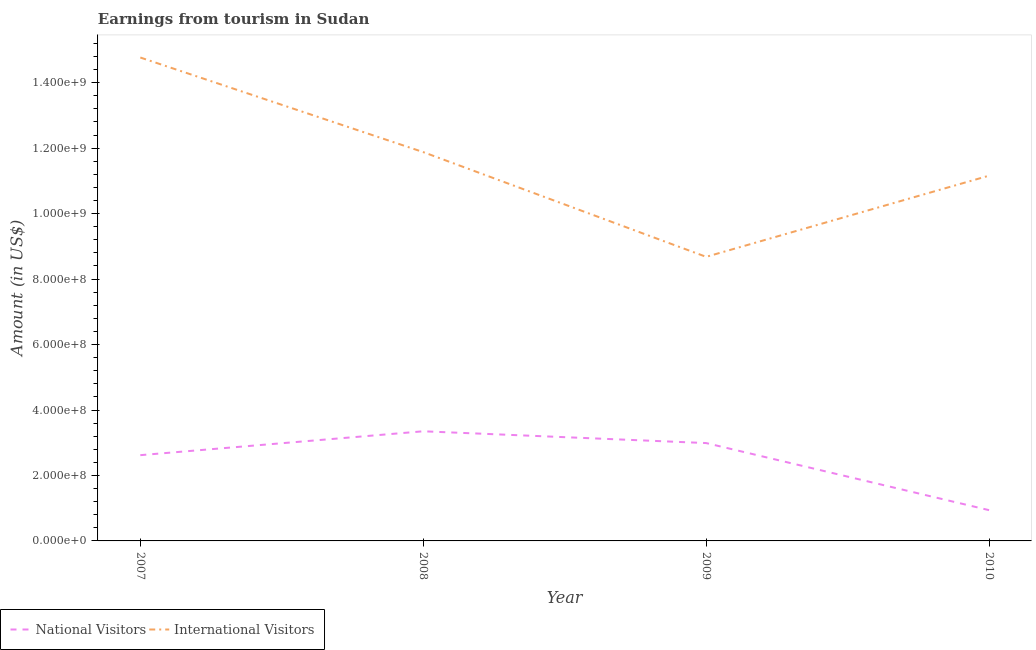How many different coloured lines are there?
Your response must be concise. 2. Does the line corresponding to amount earned from international visitors intersect with the line corresponding to amount earned from national visitors?
Provide a succinct answer. No. What is the amount earned from international visitors in 2009?
Your answer should be compact. 8.68e+08. Across all years, what is the maximum amount earned from national visitors?
Provide a short and direct response. 3.35e+08. Across all years, what is the minimum amount earned from international visitors?
Offer a terse response. 8.68e+08. What is the total amount earned from national visitors in the graph?
Offer a very short reply. 9.90e+08. What is the difference between the amount earned from international visitors in 2008 and that in 2010?
Make the answer very short. 7.20e+07. What is the difference between the amount earned from national visitors in 2008 and the amount earned from international visitors in 2009?
Make the answer very short. -5.33e+08. What is the average amount earned from international visitors per year?
Ensure brevity in your answer.  1.16e+09. In the year 2008, what is the difference between the amount earned from international visitors and amount earned from national visitors?
Provide a succinct answer. 8.53e+08. What is the ratio of the amount earned from national visitors in 2007 to that in 2008?
Keep it short and to the point. 0.78. Is the amount earned from international visitors in 2008 less than that in 2009?
Offer a terse response. No. Is the difference between the amount earned from national visitors in 2008 and 2010 greater than the difference between the amount earned from international visitors in 2008 and 2010?
Make the answer very short. Yes. What is the difference between the highest and the second highest amount earned from national visitors?
Provide a short and direct response. 3.60e+07. What is the difference between the highest and the lowest amount earned from international visitors?
Ensure brevity in your answer.  6.09e+08. Is the amount earned from international visitors strictly greater than the amount earned from national visitors over the years?
Your answer should be compact. Yes. How many years are there in the graph?
Ensure brevity in your answer.  4. What is the title of the graph?
Make the answer very short. Earnings from tourism in Sudan. What is the label or title of the X-axis?
Your answer should be compact. Year. What is the label or title of the Y-axis?
Make the answer very short. Amount (in US$). What is the Amount (in US$) in National Visitors in 2007?
Provide a short and direct response. 2.62e+08. What is the Amount (in US$) of International Visitors in 2007?
Give a very brief answer. 1.48e+09. What is the Amount (in US$) of National Visitors in 2008?
Make the answer very short. 3.35e+08. What is the Amount (in US$) of International Visitors in 2008?
Ensure brevity in your answer.  1.19e+09. What is the Amount (in US$) of National Visitors in 2009?
Your answer should be compact. 2.99e+08. What is the Amount (in US$) of International Visitors in 2009?
Keep it short and to the point. 8.68e+08. What is the Amount (in US$) in National Visitors in 2010?
Provide a short and direct response. 9.40e+07. What is the Amount (in US$) in International Visitors in 2010?
Your response must be concise. 1.12e+09. Across all years, what is the maximum Amount (in US$) in National Visitors?
Provide a short and direct response. 3.35e+08. Across all years, what is the maximum Amount (in US$) in International Visitors?
Offer a terse response. 1.48e+09. Across all years, what is the minimum Amount (in US$) of National Visitors?
Offer a terse response. 9.40e+07. Across all years, what is the minimum Amount (in US$) of International Visitors?
Offer a very short reply. 8.68e+08. What is the total Amount (in US$) in National Visitors in the graph?
Ensure brevity in your answer.  9.90e+08. What is the total Amount (in US$) in International Visitors in the graph?
Offer a very short reply. 4.65e+09. What is the difference between the Amount (in US$) of National Visitors in 2007 and that in 2008?
Ensure brevity in your answer.  -7.30e+07. What is the difference between the Amount (in US$) of International Visitors in 2007 and that in 2008?
Keep it short and to the point. 2.89e+08. What is the difference between the Amount (in US$) of National Visitors in 2007 and that in 2009?
Ensure brevity in your answer.  -3.70e+07. What is the difference between the Amount (in US$) in International Visitors in 2007 and that in 2009?
Your answer should be compact. 6.09e+08. What is the difference between the Amount (in US$) in National Visitors in 2007 and that in 2010?
Make the answer very short. 1.68e+08. What is the difference between the Amount (in US$) of International Visitors in 2007 and that in 2010?
Your answer should be very brief. 3.61e+08. What is the difference between the Amount (in US$) of National Visitors in 2008 and that in 2009?
Offer a very short reply. 3.60e+07. What is the difference between the Amount (in US$) in International Visitors in 2008 and that in 2009?
Your answer should be compact. 3.20e+08. What is the difference between the Amount (in US$) in National Visitors in 2008 and that in 2010?
Keep it short and to the point. 2.41e+08. What is the difference between the Amount (in US$) in International Visitors in 2008 and that in 2010?
Offer a terse response. 7.20e+07. What is the difference between the Amount (in US$) of National Visitors in 2009 and that in 2010?
Your answer should be compact. 2.05e+08. What is the difference between the Amount (in US$) of International Visitors in 2009 and that in 2010?
Offer a terse response. -2.48e+08. What is the difference between the Amount (in US$) in National Visitors in 2007 and the Amount (in US$) in International Visitors in 2008?
Provide a short and direct response. -9.26e+08. What is the difference between the Amount (in US$) in National Visitors in 2007 and the Amount (in US$) in International Visitors in 2009?
Ensure brevity in your answer.  -6.06e+08. What is the difference between the Amount (in US$) of National Visitors in 2007 and the Amount (in US$) of International Visitors in 2010?
Provide a short and direct response. -8.54e+08. What is the difference between the Amount (in US$) in National Visitors in 2008 and the Amount (in US$) in International Visitors in 2009?
Offer a terse response. -5.33e+08. What is the difference between the Amount (in US$) in National Visitors in 2008 and the Amount (in US$) in International Visitors in 2010?
Ensure brevity in your answer.  -7.81e+08. What is the difference between the Amount (in US$) of National Visitors in 2009 and the Amount (in US$) of International Visitors in 2010?
Your answer should be very brief. -8.17e+08. What is the average Amount (in US$) in National Visitors per year?
Make the answer very short. 2.48e+08. What is the average Amount (in US$) in International Visitors per year?
Give a very brief answer. 1.16e+09. In the year 2007, what is the difference between the Amount (in US$) in National Visitors and Amount (in US$) in International Visitors?
Offer a very short reply. -1.22e+09. In the year 2008, what is the difference between the Amount (in US$) of National Visitors and Amount (in US$) of International Visitors?
Offer a terse response. -8.53e+08. In the year 2009, what is the difference between the Amount (in US$) in National Visitors and Amount (in US$) in International Visitors?
Offer a terse response. -5.69e+08. In the year 2010, what is the difference between the Amount (in US$) of National Visitors and Amount (in US$) of International Visitors?
Ensure brevity in your answer.  -1.02e+09. What is the ratio of the Amount (in US$) of National Visitors in 2007 to that in 2008?
Offer a terse response. 0.78. What is the ratio of the Amount (in US$) of International Visitors in 2007 to that in 2008?
Your answer should be very brief. 1.24. What is the ratio of the Amount (in US$) of National Visitors in 2007 to that in 2009?
Your response must be concise. 0.88. What is the ratio of the Amount (in US$) of International Visitors in 2007 to that in 2009?
Make the answer very short. 1.7. What is the ratio of the Amount (in US$) in National Visitors in 2007 to that in 2010?
Your answer should be compact. 2.79. What is the ratio of the Amount (in US$) of International Visitors in 2007 to that in 2010?
Your answer should be compact. 1.32. What is the ratio of the Amount (in US$) of National Visitors in 2008 to that in 2009?
Your answer should be very brief. 1.12. What is the ratio of the Amount (in US$) in International Visitors in 2008 to that in 2009?
Provide a short and direct response. 1.37. What is the ratio of the Amount (in US$) in National Visitors in 2008 to that in 2010?
Offer a terse response. 3.56. What is the ratio of the Amount (in US$) of International Visitors in 2008 to that in 2010?
Keep it short and to the point. 1.06. What is the ratio of the Amount (in US$) of National Visitors in 2009 to that in 2010?
Ensure brevity in your answer.  3.18. What is the ratio of the Amount (in US$) in International Visitors in 2009 to that in 2010?
Your answer should be very brief. 0.78. What is the difference between the highest and the second highest Amount (in US$) of National Visitors?
Give a very brief answer. 3.60e+07. What is the difference between the highest and the second highest Amount (in US$) in International Visitors?
Keep it short and to the point. 2.89e+08. What is the difference between the highest and the lowest Amount (in US$) in National Visitors?
Your response must be concise. 2.41e+08. What is the difference between the highest and the lowest Amount (in US$) in International Visitors?
Provide a succinct answer. 6.09e+08. 